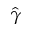Convert formula to latex. <formula><loc_0><loc_0><loc_500><loc_500>\hat { \gamma }</formula> 